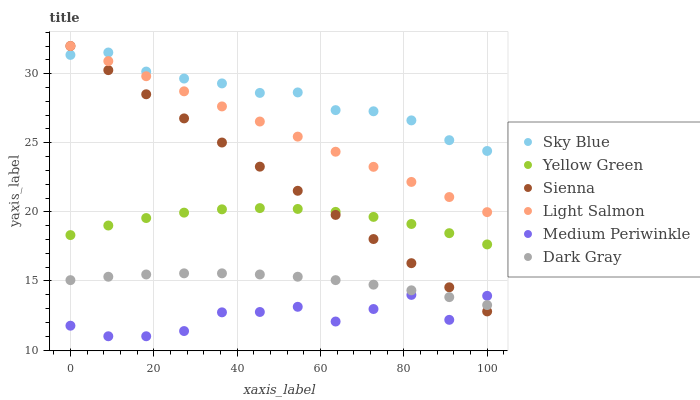Does Medium Periwinkle have the minimum area under the curve?
Answer yes or no. Yes. Does Sky Blue have the maximum area under the curve?
Answer yes or no. Yes. Does Light Salmon have the minimum area under the curve?
Answer yes or no. No. Does Light Salmon have the maximum area under the curve?
Answer yes or no. No. Is Light Salmon the smoothest?
Answer yes or no. Yes. Is Medium Periwinkle the roughest?
Answer yes or no. Yes. Is Yellow Green the smoothest?
Answer yes or no. No. Is Yellow Green the roughest?
Answer yes or no. No. Does Medium Periwinkle have the lowest value?
Answer yes or no. Yes. Does Light Salmon have the lowest value?
Answer yes or no. No. Does Sienna have the highest value?
Answer yes or no. Yes. Does Yellow Green have the highest value?
Answer yes or no. No. Is Dark Gray less than Sky Blue?
Answer yes or no. Yes. Is Yellow Green greater than Dark Gray?
Answer yes or no. Yes. Does Sienna intersect Dark Gray?
Answer yes or no. Yes. Is Sienna less than Dark Gray?
Answer yes or no. No. Is Sienna greater than Dark Gray?
Answer yes or no. No. Does Dark Gray intersect Sky Blue?
Answer yes or no. No. 